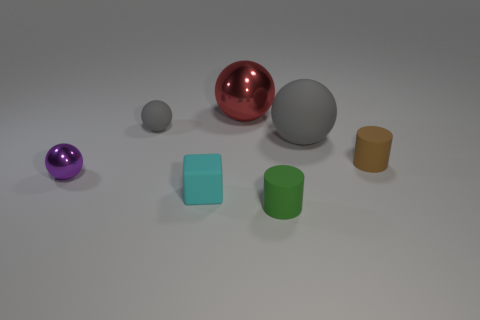Add 3 brown things. How many objects exist? 10 Subtract all cylinders. How many objects are left? 5 Add 2 metal things. How many metal things are left? 4 Add 3 large shiny things. How many large shiny things exist? 4 Subtract 0 brown balls. How many objects are left? 7 Subtract all red shiny things. Subtract all red things. How many objects are left? 5 